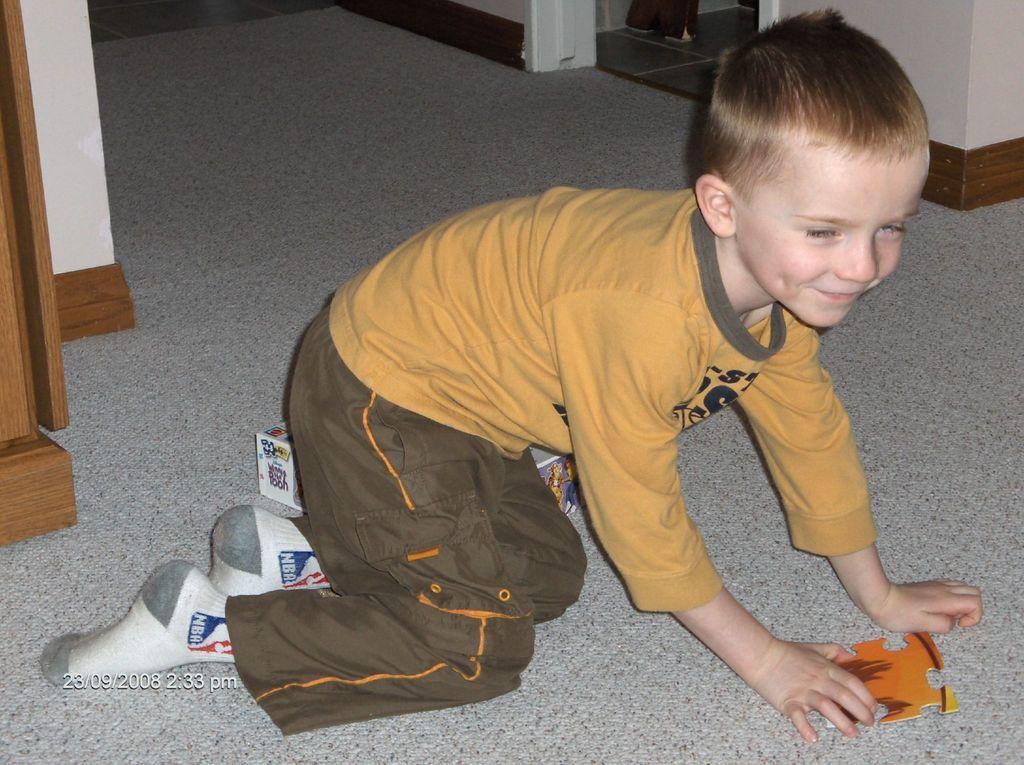Can you describe this image briefly? In this image we can see a child holding a piece of puzzle and a cardboard box on the floor. We can also see a wall. 